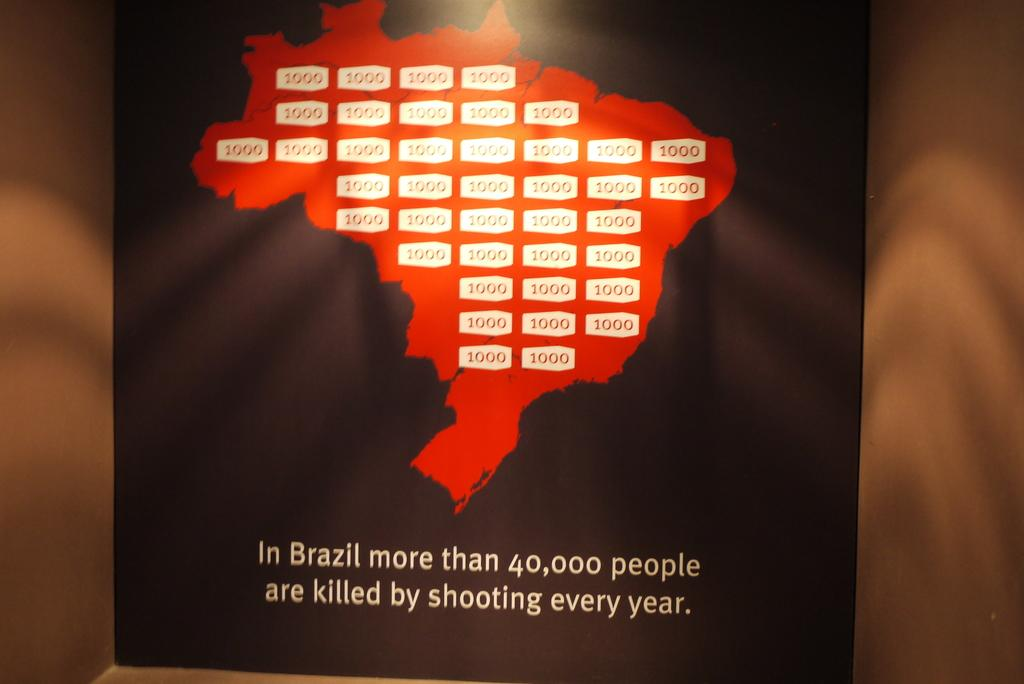<image>
Provide a brief description of the given image. A poster for shooting violence in Brazil states that 40,000 people are killed in shootings every year. 